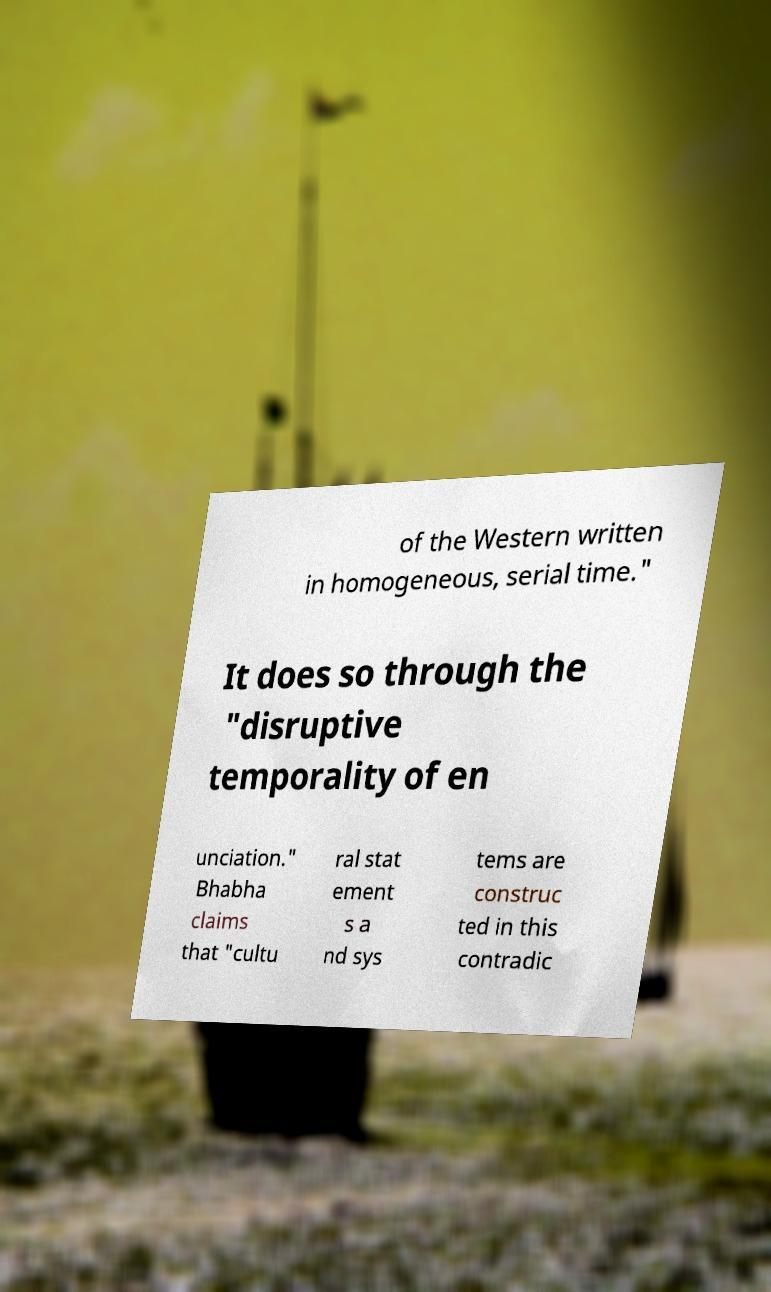Can you read and provide the text displayed in the image?This photo seems to have some interesting text. Can you extract and type it out for me? of the Western written in homogeneous, serial time." It does so through the "disruptive temporality of en unciation." Bhabha claims that "cultu ral stat ement s a nd sys tems are construc ted in this contradic 